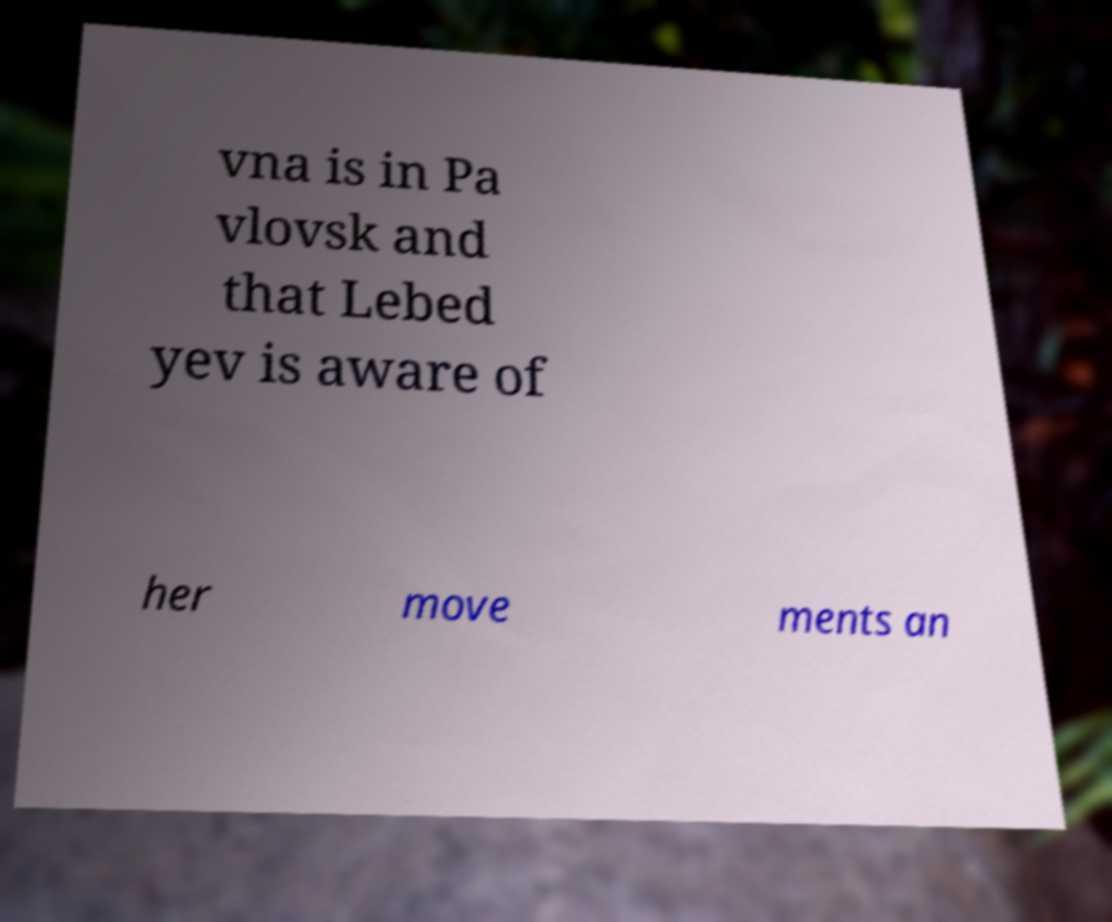Could you extract and type out the text from this image? vna is in Pa vlovsk and that Lebed yev is aware of her move ments an 